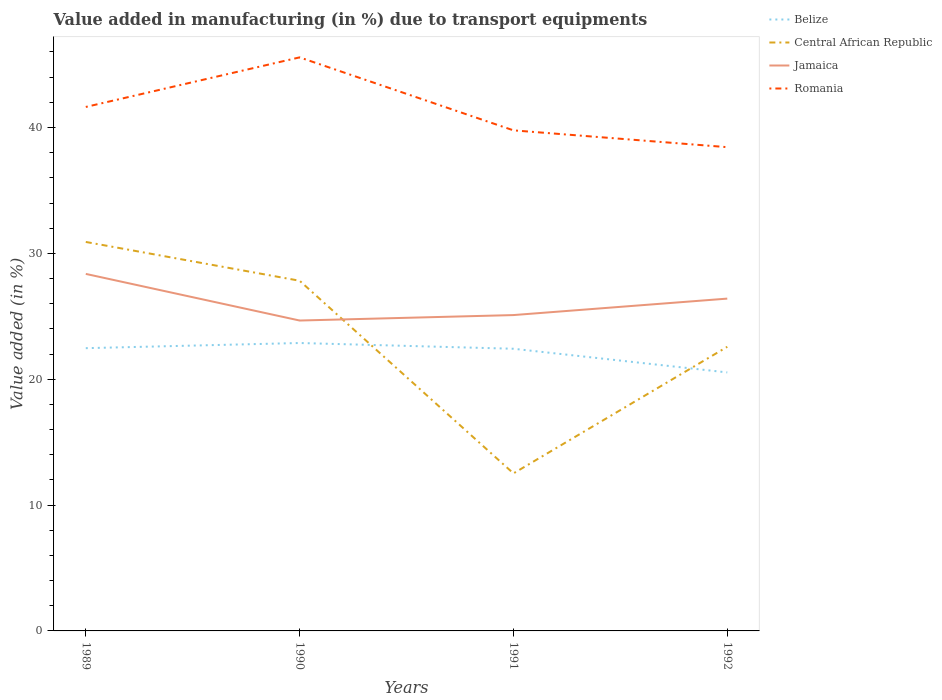How many different coloured lines are there?
Provide a succinct answer. 4. Does the line corresponding to Central African Republic intersect with the line corresponding to Romania?
Your response must be concise. No. Across all years, what is the maximum percentage of value added in manufacturing due to transport equipments in Romania?
Your answer should be very brief. 38.44. What is the total percentage of value added in manufacturing due to transport equipments in Belize in the graph?
Your answer should be compact. -0.41. What is the difference between the highest and the second highest percentage of value added in manufacturing due to transport equipments in Jamaica?
Your response must be concise. 3.7. How many years are there in the graph?
Offer a very short reply. 4. What is the difference between two consecutive major ticks on the Y-axis?
Ensure brevity in your answer.  10. Does the graph contain grids?
Ensure brevity in your answer.  No. How are the legend labels stacked?
Ensure brevity in your answer.  Vertical. What is the title of the graph?
Make the answer very short. Value added in manufacturing (in %) due to transport equipments. Does "Macedonia" appear as one of the legend labels in the graph?
Your response must be concise. No. What is the label or title of the X-axis?
Your answer should be compact. Years. What is the label or title of the Y-axis?
Offer a terse response. Value added (in %). What is the Value added (in %) of Belize in 1989?
Provide a succinct answer. 22.47. What is the Value added (in %) in Central African Republic in 1989?
Your answer should be very brief. 30.91. What is the Value added (in %) in Jamaica in 1989?
Provide a succinct answer. 28.37. What is the Value added (in %) of Romania in 1989?
Your answer should be compact. 41.63. What is the Value added (in %) of Belize in 1990?
Your answer should be very brief. 22.88. What is the Value added (in %) in Central African Republic in 1990?
Offer a terse response. 27.82. What is the Value added (in %) in Jamaica in 1990?
Your response must be concise. 24.66. What is the Value added (in %) in Romania in 1990?
Your response must be concise. 45.57. What is the Value added (in %) of Belize in 1991?
Offer a very short reply. 22.42. What is the Value added (in %) of Central African Republic in 1991?
Ensure brevity in your answer.  12.52. What is the Value added (in %) in Jamaica in 1991?
Ensure brevity in your answer.  25.1. What is the Value added (in %) in Romania in 1991?
Your answer should be compact. 39.77. What is the Value added (in %) of Belize in 1992?
Give a very brief answer. 20.54. What is the Value added (in %) in Central African Republic in 1992?
Ensure brevity in your answer.  22.58. What is the Value added (in %) of Jamaica in 1992?
Offer a very short reply. 26.4. What is the Value added (in %) in Romania in 1992?
Make the answer very short. 38.44. Across all years, what is the maximum Value added (in %) of Belize?
Your response must be concise. 22.88. Across all years, what is the maximum Value added (in %) in Central African Republic?
Keep it short and to the point. 30.91. Across all years, what is the maximum Value added (in %) of Jamaica?
Ensure brevity in your answer.  28.37. Across all years, what is the maximum Value added (in %) of Romania?
Your answer should be very brief. 45.57. Across all years, what is the minimum Value added (in %) in Belize?
Your answer should be very brief. 20.54. Across all years, what is the minimum Value added (in %) of Central African Republic?
Give a very brief answer. 12.52. Across all years, what is the minimum Value added (in %) in Jamaica?
Keep it short and to the point. 24.66. Across all years, what is the minimum Value added (in %) of Romania?
Your response must be concise. 38.44. What is the total Value added (in %) of Belize in the graph?
Your response must be concise. 88.3. What is the total Value added (in %) of Central African Republic in the graph?
Offer a terse response. 93.83. What is the total Value added (in %) in Jamaica in the graph?
Make the answer very short. 104.53. What is the total Value added (in %) in Romania in the graph?
Your response must be concise. 165.42. What is the difference between the Value added (in %) in Belize in 1989 and that in 1990?
Keep it short and to the point. -0.41. What is the difference between the Value added (in %) in Central African Republic in 1989 and that in 1990?
Your answer should be very brief. 3.08. What is the difference between the Value added (in %) of Jamaica in 1989 and that in 1990?
Make the answer very short. 3.7. What is the difference between the Value added (in %) in Romania in 1989 and that in 1990?
Your response must be concise. -3.94. What is the difference between the Value added (in %) in Belize in 1989 and that in 1991?
Make the answer very short. 0.05. What is the difference between the Value added (in %) of Central African Republic in 1989 and that in 1991?
Provide a succinct answer. 18.39. What is the difference between the Value added (in %) in Jamaica in 1989 and that in 1991?
Ensure brevity in your answer.  3.27. What is the difference between the Value added (in %) of Romania in 1989 and that in 1991?
Offer a very short reply. 1.86. What is the difference between the Value added (in %) of Belize in 1989 and that in 1992?
Offer a very short reply. 1.93. What is the difference between the Value added (in %) of Central African Republic in 1989 and that in 1992?
Offer a terse response. 8.33. What is the difference between the Value added (in %) of Jamaica in 1989 and that in 1992?
Offer a very short reply. 1.96. What is the difference between the Value added (in %) in Romania in 1989 and that in 1992?
Your answer should be compact. 3.2. What is the difference between the Value added (in %) of Belize in 1990 and that in 1991?
Ensure brevity in your answer.  0.46. What is the difference between the Value added (in %) in Central African Republic in 1990 and that in 1991?
Your response must be concise. 15.31. What is the difference between the Value added (in %) of Jamaica in 1990 and that in 1991?
Ensure brevity in your answer.  -0.43. What is the difference between the Value added (in %) in Romania in 1990 and that in 1991?
Provide a succinct answer. 5.8. What is the difference between the Value added (in %) of Belize in 1990 and that in 1992?
Ensure brevity in your answer.  2.34. What is the difference between the Value added (in %) of Central African Republic in 1990 and that in 1992?
Give a very brief answer. 5.25. What is the difference between the Value added (in %) of Jamaica in 1990 and that in 1992?
Give a very brief answer. -1.74. What is the difference between the Value added (in %) in Romania in 1990 and that in 1992?
Offer a terse response. 7.13. What is the difference between the Value added (in %) of Belize in 1991 and that in 1992?
Keep it short and to the point. 1.88. What is the difference between the Value added (in %) of Central African Republic in 1991 and that in 1992?
Provide a short and direct response. -10.06. What is the difference between the Value added (in %) in Jamaica in 1991 and that in 1992?
Make the answer very short. -1.31. What is the difference between the Value added (in %) in Romania in 1991 and that in 1992?
Provide a short and direct response. 1.34. What is the difference between the Value added (in %) in Belize in 1989 and the Value added (in %) in Central African Republic in 1990?
Your response must be concise. -5.36. What is the difference between the Value added (in %) in Belize in 1989 and the Value added (in %) in Jamaica in 1990?
Keep it short and to the point. -2.2. What is the difference between the Value added (in %) of Belize in 1989 and the Value added (in %) of Romania in 1990?
Provide a succinct answer. -23.11. What is the difference between the Value added (in %) in Central African Republic in 1989 and the Value added (in %) in Jamaica in 1990?
Your answer should be compact. 6.24. What is the difference between the Value added (in %) in Central African Republic in 1989 and the Value added (in %) in Romania in 1990?
Ensure brevity in your answer.  -14.67. What is the difference between the Value added (in %) of Jamaica in 1989 and the Value added (in %) of Romania in 1990?
Make the answer very short. -17.2. What is the difference between the Value added (in %) in Belize in 1989 and the Value added (in %) in Central African Republic in 1991?
Offer a terse response. 9.95. What is the difference between the Value added (in %) of Belize in 1989 and the Value added (in %) of Jamaica in 1991?
Offer a terse response. -2.63. What is the difference between the Value added (in %) of Belize in 1989 and the Value added (in %) of Romania in 1991?
Offer a terse response. -17.31. What is the difference between the Value added (in %) of Central African Republic in 1989 and the Value added (in %) of Jamaica in 1991?
Ensure brevity in your answer.  5.81. What is the difference between the Value added (in %) of Central African Republic in 1989 and the Value added (in %) of Romania in 1991?
Ensure brevity in your answer.  -8.87. What is the difference between the Value added (in %) in Jamaica in 1989 and the Value added (in %) in Romania in 1991?
Make the answer very short. -11.41. What is the difference between the Value added (in %) of Belize in 1989 and the Value added (in %) of Central African Republic in 1992?
Keep it short and to the point. -0.11. What is the difference between the Value added (in %) of Belize in 1989 and the Value added (in %) of Jamaica in 1992?
Offer a terse response. -3.94. What is the difference between the Value added (in %) of Belize in 1989 and the Value added (in %) of Romania in 1992?
Offer a very short reply. -15.97. What is the difference between the Value added (in %) in Central African Republic in 1989 and the Value added (in %) in Jamaica in 1992?
Ensure brevity in your answer.  4.5. What is the difference between the Value added (in %) of Central African Republic in 1989 and the Value added (in %) of Romania in 1992?
Make the answer very short. -7.53. What is the difference between the Value added (in %) in Jamaica in 1989 and the Value added (in %) in Romania in 1992?
Give a very brief answer. -10.07. What is the difference between the Value added (in %) in Belize in 1990 and the Value added (in %) in Central African Republic in 1991?
Your answer should be compact. 10.36. What is the difference between the Value added (in %) in Belize in 1990 and the Value added (in %) in Jamaica in 1991?
Your answer should be very brief. -2.22. What is the difference between the Value added (in %) of Belize in 1990 and the Value added (in %) of Romania in 1991?
Give a very brief answer. -16.9. What is the difference between the Value added (in %) in Central African Republic in 1990 and the Value added (in %) in Jamaica in 1991?
Provide a short and direct response. 2.73. What is the difference between the Value added (in %) of Central African Republic in 1990 and the Value added (in %) of Romania in 1991?
Your answer should be compact. -11.95. What is the difference between the Value added (in %) in Jamaica in 1990 and the Value added (in %) in Romania in 1991?
Your answer should be very brief. -15.11. What is the difference between the Value added (in %) in Belize in 1990 and the Value added (in %) in Central African Republic in 1992?
Provide a short and direct response. 0.3. What is the difference between the Value added (in %) of Belize in 1990 and the Value added (in %) of Jamaica in 1992?
Offer a terse response. -3.53. What is the difference between the Value added (in %) of Belize in 1990 and the Value added (in %) of Romania in 1992?
Provide a short and direct response. -15.56. What is the difference between the Value added (in %) in Central African Republic in 1990 and the Value added (in %) in Jamaica in 1992?
Your answer should be compact. 1.42. What is the difference between the Value added (in %) in Central African Republic in 1990 and the Value added (in %) in Romania in 1992?
Make the answer very short. -10.61. What is the difference between the Value added (in %) of Jamaica in 1990 and the Value added (in %) of Romania in 1992?
Give a very brief answer. -13.77. What is the difference between the Value added (in %) in Belize in 1991 and the Value added (in %) in Central African Republic in 1992?
Provide a short and direct response. -0.16. What is the difference between the Value added (in %) of Belize in 1991 and the Value added (in %) of Jamaica in 1992?
Your answer should be very brief. -3.98. What is the difference between the Value added (in %) of Belize in 1991 and the Value added (in %) of Romania in 1992?
Your answer should be very brief. -16.02. What is the difference between the Value added (in %) of Central African Republic in 1991 and the Value added (in %) of Jamaica in 1992?
Make the answer very short. -13.89. What is the difference between the Value added (in %) of Central African Republic in 1991 and the Value added (in %) of Romania in 1992?
Give a very brief answer. -25.92. What is the difference between the Value added (in %) in Jamaica in 1991 and the Value added (in %) in Romania in 1992?
Your answer should be very brief. -13.34. What is the average Value added (in %) of Belize per year?
Offer a terse response. 22.08. What is the average Value added (in %) of Central African Republic per year?
Provide a short and direct response. 23.46. What is the average Value added (in %) of Jamaica per year?
Keep it short and to the point. 26.13. What is the average Value added (in %) of Romania per year?
Provide a short and direct response. 41.35. In the year 1989, what is the difference between the Value added (in %) in Belize and Value added (in %) in Central African Republic?
Ensure brevity in your answer.  -8.44. In the year 1989, what is the difference between the Value added (in %) in Belize and Value added (in %) in Jamaica?
Provide a succinct answer. -5.9. In the year 1989, what is the difference between the Value added (in %) of Belize and Value added (in %) of Romania?
Keep it short and to the point. -19.17. In the year 1989, what is the difference between the Value added (in %) of Central African Republic and Value added (in %) of Jamaica?
Your answer should be very brief. 2.54. In the year 1989, what is the difference between the Value added (in %) of Central African Republic and Value added (in %) of Romania?
Give a very brief answer. -10.73. In the year 1989, what is the difference between the Value added (in %) of Jamaica and Value added (in %) of Romania?
Give a very brief answer. -13.27. In the year 1990, what is the difference between the Value added (in %) of Belize and Value added (in %) of Central African Republic?
Provide a short and direct response. -4.95. In the year 1990, what is the difference between the Value added (in %) of Belize and Value added (in %) of Jamaica?
Your response must be concise. -1.79. In the year 1990, what is the difference between the Value added (in %) of Belize and Value added (in %) of Romania?
Offer a terse response. -22.7. In the year 1990, what is the difference between the Value added (in %) of Central African Republic and Value added (in %) of Jamaica?
Ensure brevity in your answer.  3.16. In the year 1990, what is the difference between the Value added (in %) of Central African Republic and Value added (in %) of Romania?
Give a very brief answer. -17.75. In the year 1990, what is the difference between the Value added (in %) in Jamaica and Value added (in %) in Romania?
Offer a very short reply. -20.91. In the year 1991, what is the difference between the Value added (in %) of Belize and Value added (in %) of Central African Republic?
Offer a very short reply. 9.9. In the year 1991, what is the difference between the Value added (in %) in Belize and Value added (in %) in Jamaica?
Keep it short and to the point. -2.68. In the year 1991, what is the difference between the Value added (in %) in Belize and Value added (in %) in Romania?
Make the answer very short. -17.35. In the year 1991, what is the difference between the Value added (in %) in Central African Republic and Value added (in %) in Jamaica?
Ensure brevity in your answer.  -12.58. In the year 1991, what is the difference between the Value added (in %) of Central African Republic and Value added (in %) of Romania?
Your answer should be very brief. -27.26. In the year 1991, what is the difference between the Value added (in %) of Jamaica and Value added (in %) of Romania?
Ensure brevity in your answer.  -14.68. In the year 1992, what is the difference between the Value added (in %) of Belize and Value added (in %) of Central African Republic?
Offer a terse response. -2.04. In the year 1992, what is the difference between the Value added (in %) of Belize and Value added (in %) of Jamaica?
Offer a terse response. -5.87. In the year 1992, what is the difference between the Value added (in %) in Belize and Value added (in %) in Romania?
Ensure brevity in your answer.  -17.9. In the year 1992, what is the difference between the Value added (in %) in Central African Republic and Value added (in %) in Jamaica?
Your answer should be very brief. -3.83. In the year 1992, what is the difference between the Value added (in %) of Central African Republic and Value added (in %) of Romania?
Give a very brief answer. -15.86. In the year 1992, what is the difference between the Value added (in %) of Jamaica and Value added (in %) of Romania?
Offer a terse response. -12.03. What is the ratio of the Value added (in %) in Belize in 1989 to that in 1990?
Provide a short and direct response. 0.98. What is the ratio of the Value added (in %) of Central African Republic in 1989 to that in 1990?
Your answer should be compact. 1.11. What is the ratio of the Value added (in %) of Jamaica in 1989 to that in 1990?
Your answer should be very brief. 1.15. What is the ratio of the Value added (in %) in Romania in 1989 to that in 1990?
Provide a succinct answer. 0.91. What is the ratio of the Value added (in %) in Central African Republic in 1989 to that in 1991?
Provide a succinct answer. 2.47. What is the ratio of the Value added (in %) of Jamaica in 1989 to that in 1991?
Give a very brief answer. 1.13. What is the ratio of the Value added (in %) of Romania in 1989 to that in 1991?
Your answer should be compact. 1.05. What is the ratio of the Value added (in %) of Belize in 1989 to that in 1992?
Offer a terse response. 1.09. What is the ratio of the Value added (in %) of Central African Republic in 1989 to that in 1992?
Provide a short and direct response. 1.37. What is the ratio of the Value added (in %) of Jamaica in 1989 to that in 1992?
Provide a short and direct response. 1.07. What is the ratio of the Value added (in %) in Romania in 1989 to that in 1992?
Keep it short and to the point. 1.08. What is the ratio of the Value added (in %) in Belize in 1990 to that in 1991?
Offer a very short reply. 1.02. What is the ratio of the Value added (in %) in Central African Republic in 1990 to that in 1991?
Offer a terse response. 2.22. What is the ratio of the Value added (in %) of Jamaica in 1990 to that in 1991?
Offer a terse response. 0.98. What is the ratio of the Value added (in %) of Romania in 1990 to that in 1991?
Keep it short and to the point. 1.15. What is the ratio of the Value added (in %) of Belize in 1990 to that in 1992?
Your response must be concise. 1.11. What is the ratio of the Value added (in %) in Central African Republic in 1990 to that in 1992?
Ensure brevity in your answer.  1.23. What is the ratio of the Value added (in %) of Jamaica in 1990 to that in 1992?
Provide a short and direct response. 0.93. What is the ratio of the Value added (in %) of Romania in 1990 to that in 1992?
Ensure brevity in your answer.  1.19. What is the ratio of the Value added (in %) of Belize in 1991 to that in 1992?
Your answer should be very brief. 1.09. What is the ratio of the Value added (in %) of Central African Republic in 1991 to that in 1992?
Provide a succinct answer. 0.55. What is the ratio of the Value added (in %) of Jamaica in 1991 to that in 1992?
Keep it short and to the point. 0.95. What is the ratio of the Value added (in %) of Romania in 1991 to that in 1992?
Offer a very short reply. 1.03. What is the difference between the highest and the second highest Value added (in %) of Belize?
Ensure brevity in your answer.  0.41. What is the difference between the highest and the second highest Value added (in %) of Central African Republic?
Provide a succinct answer. 3.08. What is the difference between the highest and the second highest Value added (in %) in Jamaica?
Your response must be concise. 1.96. What is the difference between the highest and the second highest Value added (in %) of Romania?
Make the answer very short. 3.94. What is the difference between the highest and the lowest Value added (in %) of Belize?
Provide a succinct answer. 2.34. What is the difference between the highest and the lowest Value added (in %) of Central African Republic?
Your response must be concise. 18.39. What is the difference between the highest and the lowest Value added (in %) of Jamaica?
Your answer should be compact. 3.7. What is the difference between the highest and the lowest Value added (in %) of Romania?
Provide a short and direct response. 7.13. 